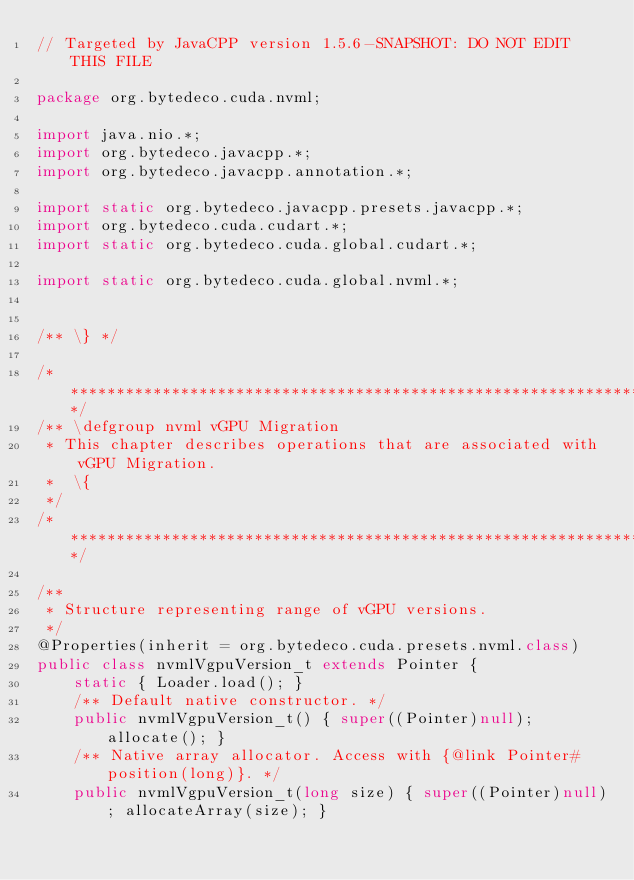Convert code to text. <code><loc_0><loc_0><loc_500><loc_500><_Java_>// Targeted by JavaCPP version 1.5.6-SNAPSHOT: DO NOT EDIT THIS FILE

package org.bytedeco.cuda.nvml;

import java.nio.*;
import org.bytedeco.javacpp.*;
import org.bytedeco.javacpp.annotation.*;

import static org.bytedeco.javacpp.presets.javacpp.*;
import org.bytedeco.cuda.cudart.*;
import static org.bytedeco.cuda.global.cudart.*;

import static org.bytedeco.cuda.global.nvml.*;


/** \} */

/***************************************************************************************************/
/** \defgroup nvml vGPU Migration
 * This chapter describes operations that are associated with vGPU Migration.
 *  \{
 */
/***************************************************************************************************/

/**
 * Structure representing range of vGPU versions.
 */
@Properties(inherit = org.bytedeco.cuda.presets.nvml.class)
public class nvmlVgpuVersion_t extends Pointer {
    static { Loader.load(); }
    /** Default native constructor. */
    public nvmlVgpuVersion_t() { super((Pointer)null); allocate(); }
    /** Native array allocator. Access with {@link Pointer#position(long)}. */
    public nvmlVgpuVersion_t(long size) { super((Pointer)null); allocateArray(size); }</code> 